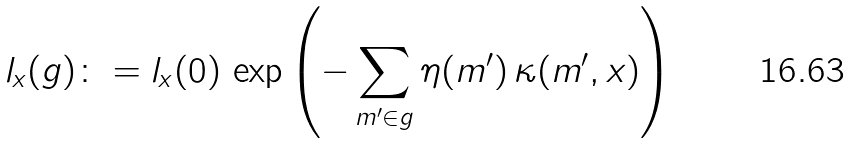Convert formula to latex. <formula><loc_0><loc_0><loc_500><loc_500>l _ { x } ( g ) \colon = l _ { x } ( 0 ) \, \exp \left ( - \sum _ { m ^ { \prime } \in g } \eta ( m ^ { \prime } ) \, \kappa ( m ^ { \prime } , x ) \right )</formula> 